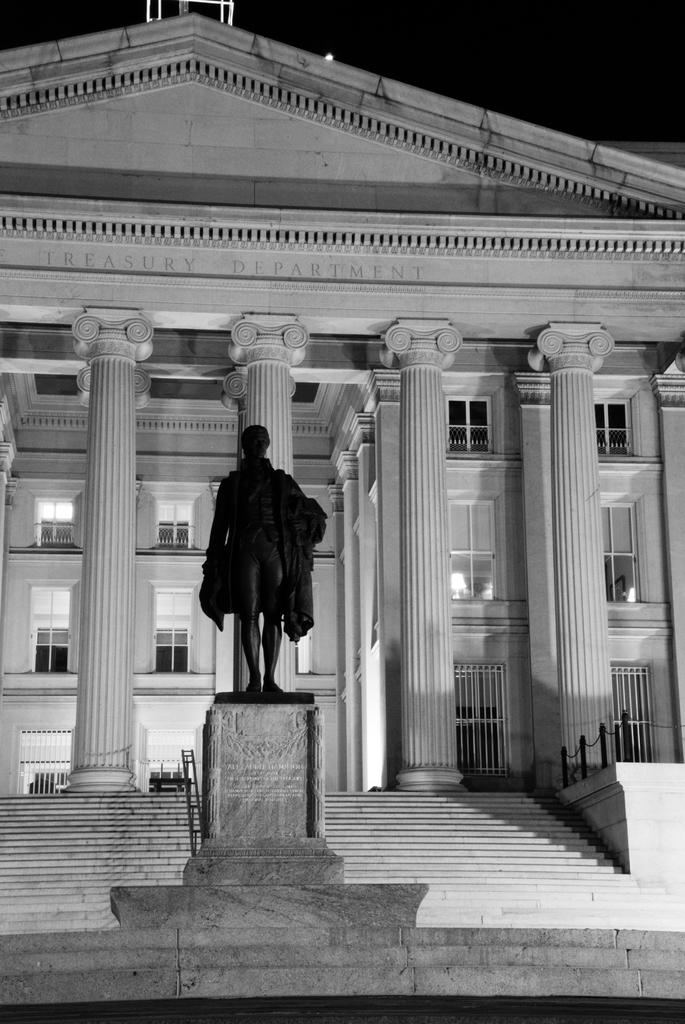What is the main subject in the foreground of the image? There is a statue in the foreground of the image. What can be seen in the background of the image? There is a big building in the background of the image. What type of jewel is the queen wearing in the image? There is no queen or jewel present in the image; it only features a statue and a big building. 